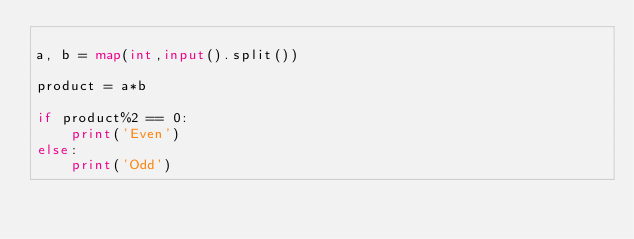Convert code to text. <code><loc_0><loc_0><loc_500><loc_500><_Python_>
a, b = map(int,input().split())

product = a*b

if product%2 == 0:
    print('Even')
else:
    print('Odd')
</code> 